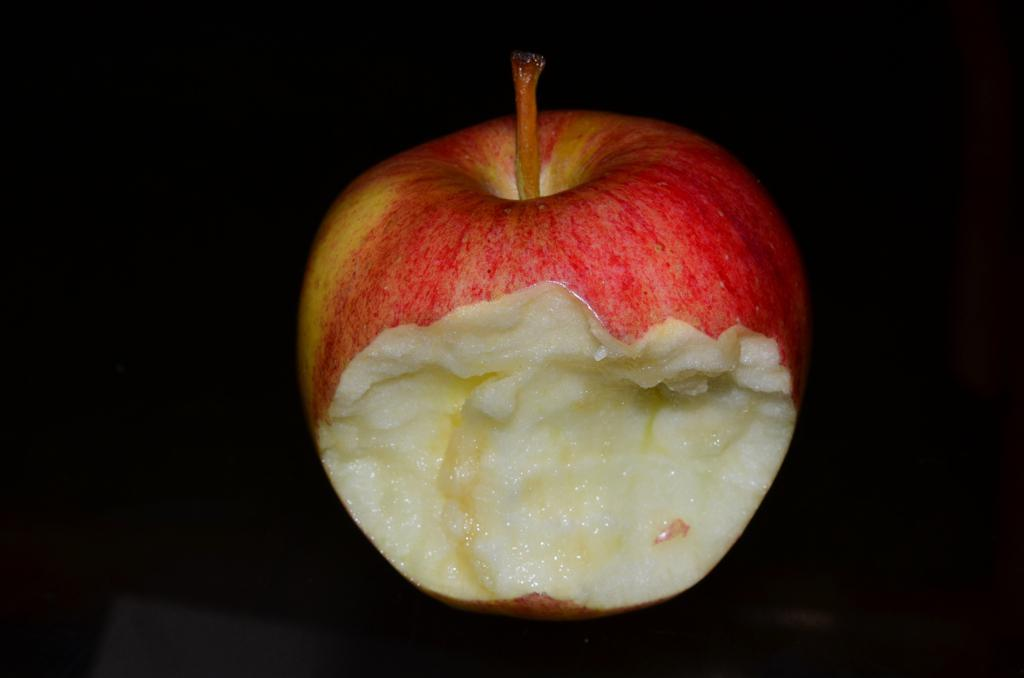What type of fruit is visible in the image? There is a half-eaten apple in the image. What route does the family take to show respect for the apple in the image? There is no mention of a family or respect in the image, and the image only features a half-eaten apple. 